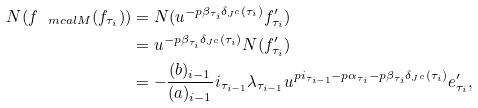Convert formula to latex. <formula><loc_0><loc_0><loc_500><loc_500>N ( f _ { \ m c a l { M } } ( f _ { \tau _ { i } } ) ) & = N ( u ^ { - p \beta _ { \tau _ { i } } \delta _ { J ^ { c } } ( \tau _ { i } ) } f ^ { \prime } _ { \tau _ { i } } ) \\ & = u ^ { - p \beta _ { \tau _ { i } } \delta _ { J ^ { c } } ( \tau _ { i } ) } N ( f ^ { \prime } _ { \tau _ { i } } ) \\ & = - \frac { ( b ) _ { i - 1 } } { ( a ) _ { i - 1 } } i _ { \tau _ { i - 1 } } \lambda _ { \tau _ { i - 1 } } u ^ { p i _ { \tau _ { i - 1 } } - p \alpha _ { \tau _ { i } } - p \beta _ { \tau _ { i } } \delta _ { J ^ { c } } ( \tau _ { i } ) } e ^ { \prime } _ { \tau _ { i } } ,</formula> 